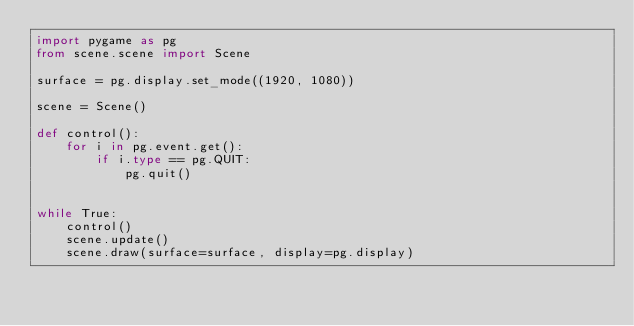Convert code to text. <code><loc_0><loc_0><loc_500><loc_500><_Python_>import pygame as pg
from scene.scene import Scene

surface = pg.display.set_mode((1920, 1080))

scene = Scene()

def control():
    for i in pg.event.get():
        if i.type == pg.QUIT:
            pg.quit()


while True:
    control()
    scene.update()
    scene.draw(surface=surface, display=pg.display)
</code> 